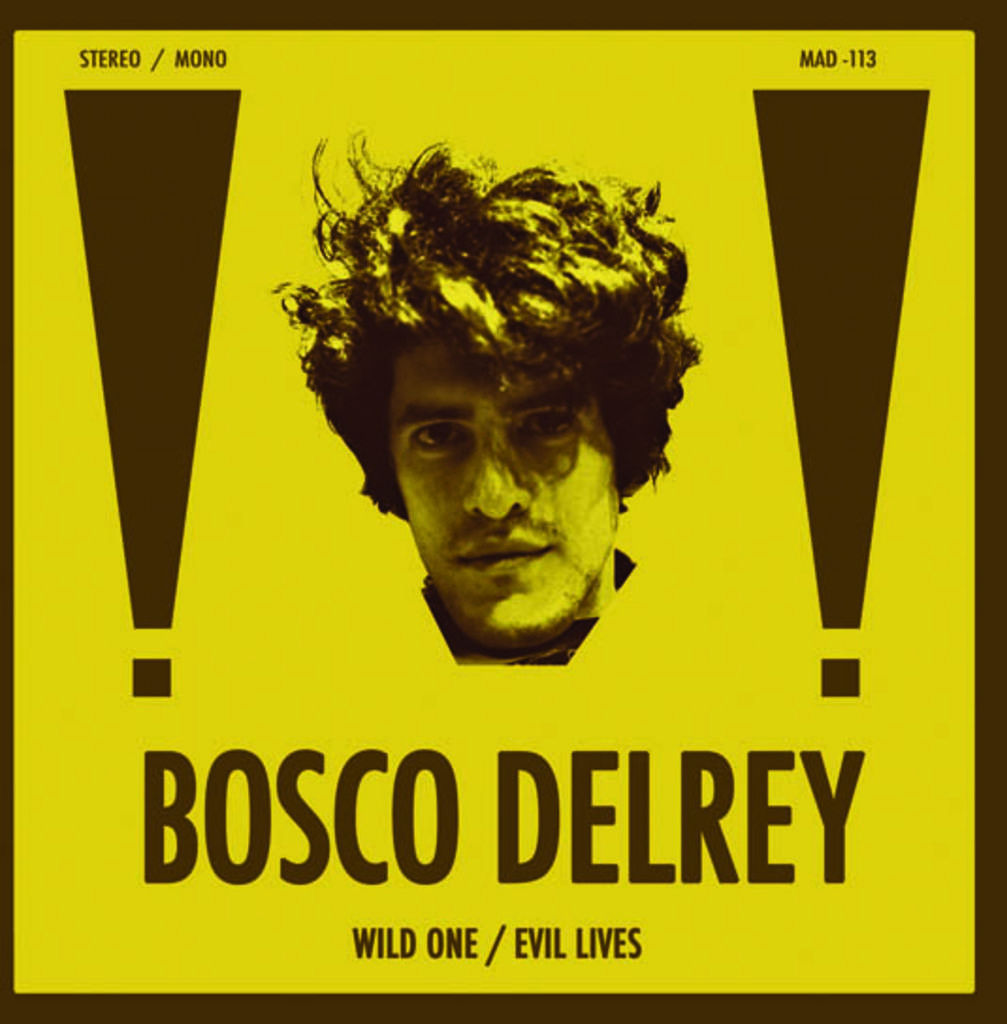What is the main subject of the image? There is a poster in the image. What is depicted on the poster? A person's face is in the center of the poster. Is there any text on the poster? Yes, there is text at the bottom of the poster. What type of toy is the person holding in the image? There is no toy present in the image; it only features a poster with a person's face and text at the bottom. 